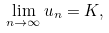<formula> <loc_0><loc_0><loc_500><loc_500>\lim _ { n \to \infty } u _ { n } = K ,</formula> 